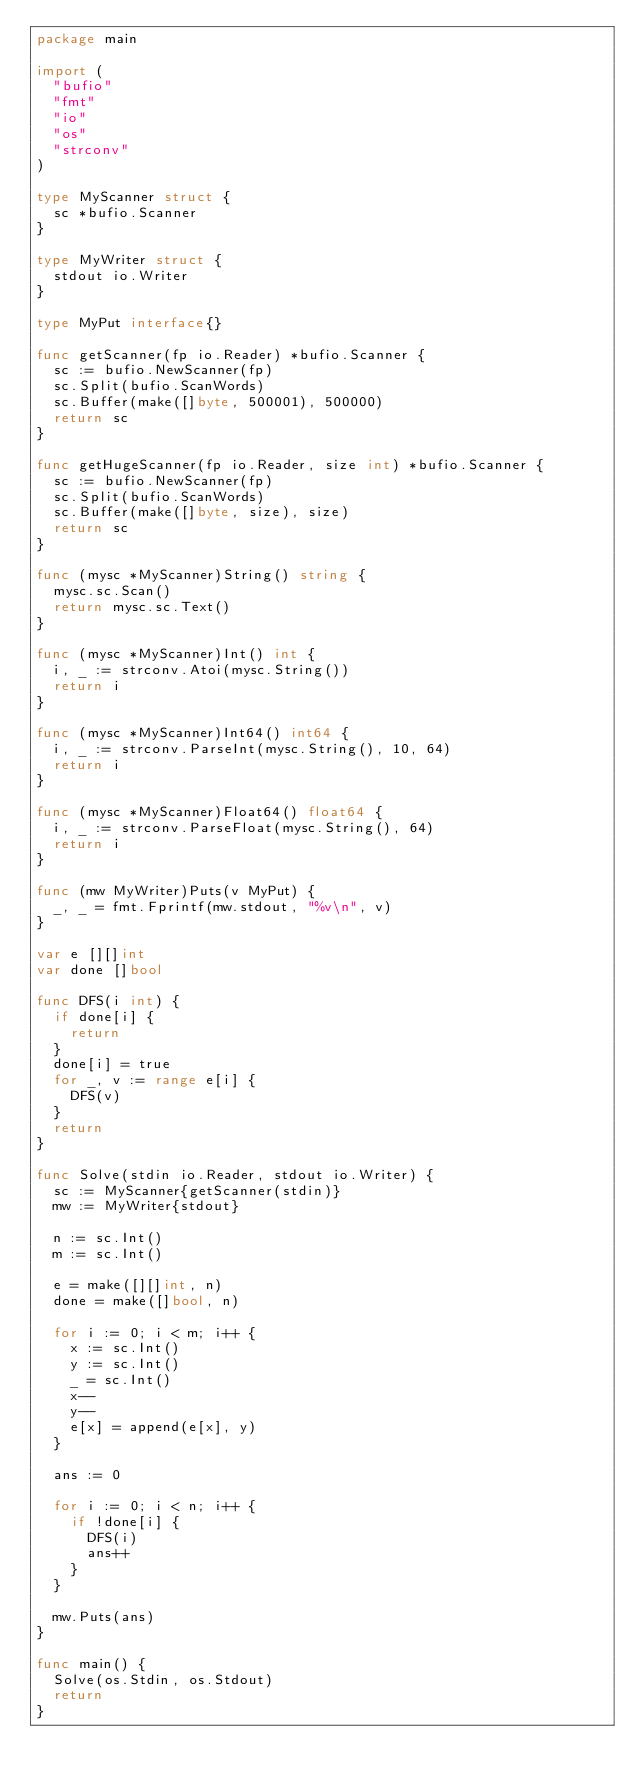Convert code to text. <code><loc_0><loc_0><loc_500><loc_500><_Go_>package main

import (
	"bufio"
	"fmt"
	"io"
	"os"
	"strconv"
)

type MyScanner struct {
	sc *bufio.Scanner
}

type MyWriter struct {
	stdout io.Writer
}

type MyPut interface{}

func getScanner(fp io.Reader) *bufio.Scanner {
	sc := bufio.NewScanner(fp)
	sc.Split(bufio.ScanWords)
	sc.Buffer(make([]byte, 500001), 500000)
	return sc
}

func getHugeScanner(fp io.Reader, size int) *bufio.Scanner {
	sc := bufio.NewScanner(fp)
	sc.Split(bufio.ScanWords)
	sc.Buffer(make([]byte, size), size)
	return sc
}

func (mysc *MyScanner)String() string {
	mysc.sc.Scan()
	return mysc.sc.Text()
}

func (mysc *MyScanner)Int() int {
	i, _ := strconv.Atoi(mysc.String())
	return i
}

func (mysc *MyScanner)Int64() int64 {
	i, _ := strconv.ParseInt(mysc.String(), 10, 64)
	return i
}

func (mysc *MyScanner)Float64() float64 {
	i, _ := strconv.ParseFloat(mysc.String(), 64)
	return i
}

func (mw MyWriter)Puts(v MyPut) {
	_, _ = fmt.Fprintf(mw.stdout, "%v\n", v)
}

var e [][]int
var done []bool

func DFS(i int) {
	if done[i] {
		return
	}
	done[i] = true
	for _, v := range e[i] {
		DFS(v)
	}
	return
}

func Solve(stdin io.Reader, stdout io.Writer) {
	sc := MyScanner{getScanner(stdin)}
	mw := MyWriter{stdout}

	n := sc.Int()
	m := sc.Int()

	e = make([][]int, n)
	done = make([]bool, n)

	for i := 0; i < m; i++ {
		x := sc.Int()
		y := sc.Int()
		_ = sc.Int()
		x--
		y--
		e[x] = append(e[x], y)
	}

	ans := 0

	for i := 0; i < n; i++ {
		if !done[i] {
			DFS(i)
			ans++
		}
	}

	mw.Puts(ans)
}

func main() {
	Solve(os.Stdin, os.Stdout)
	return
}</code> 